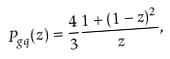<formula> <loc_0><loc_0><loc_500><loc_500>P _ { g q } ( z ) = \frac { 4 } { 3 } \frac { 1 + ( 1 - z ) ^ { 2 } } { z } ,</formula> 